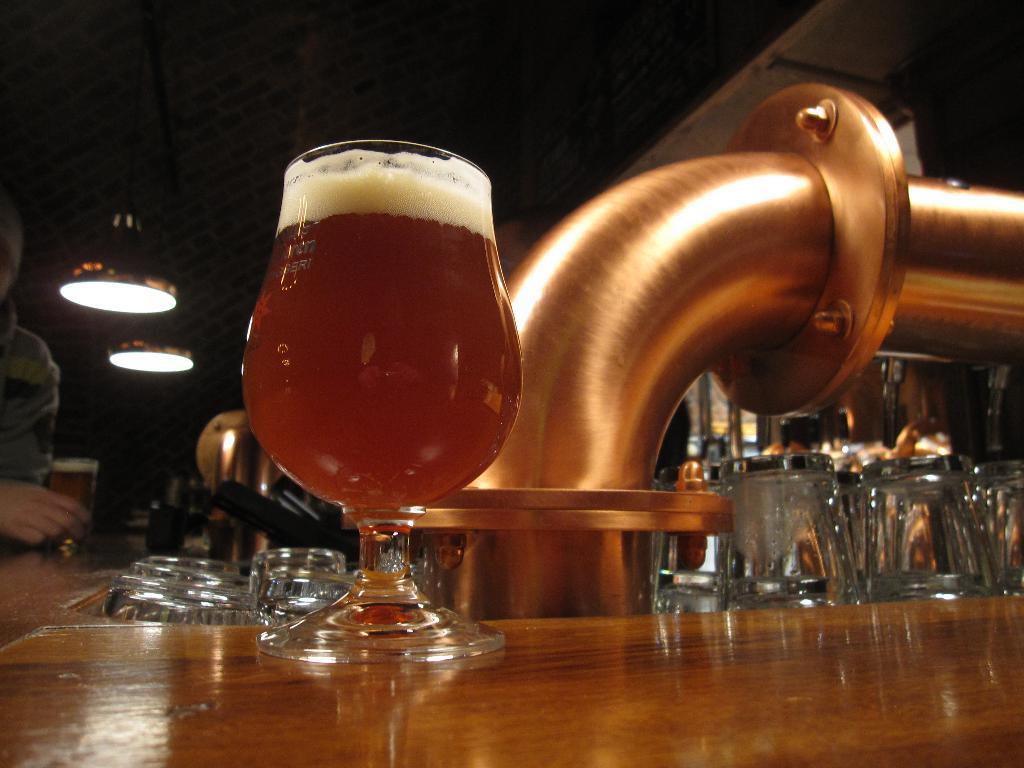Could you give a brief overview of what you see in this image? In the picture we can see a wooden table on it, we can see a glass with wine in it and beside it, we can see a pipe with copper made and some glasses beside it and near the table, we can see a part of the person holding a wine glass and to the ceiling we can see two lights. 